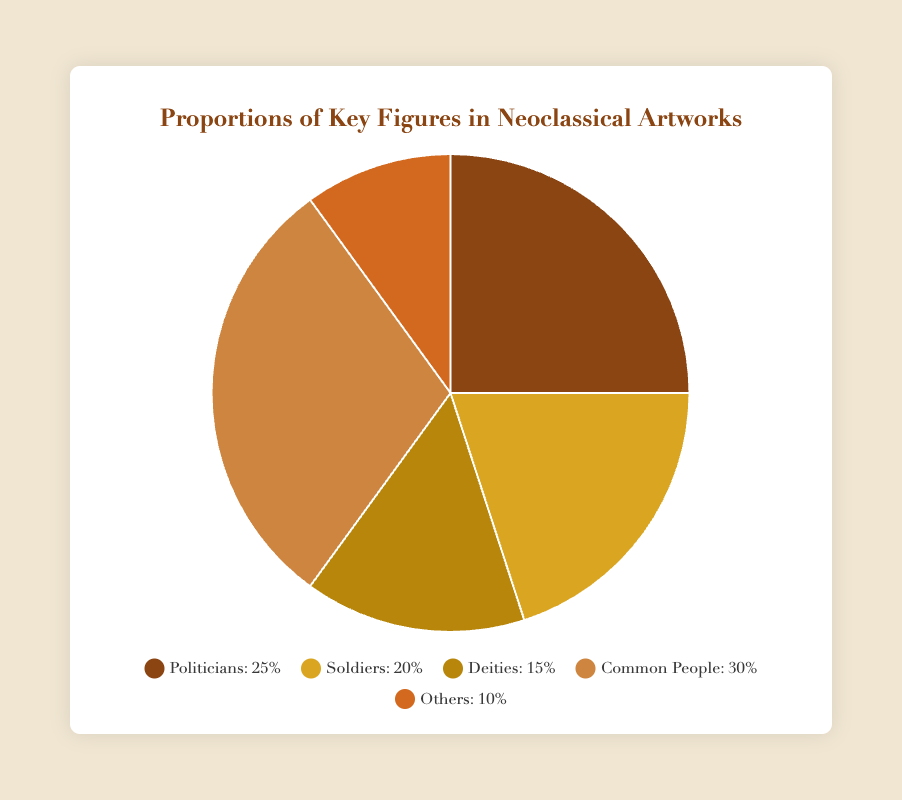What is the proportion of artworks depicting common people? The figure shows that common people make up 30% of the key figures in Neoclassical artworks.
Answer: 30% Which role has the lowest representation in Neoclassical artworks? The figure indicates that the "Others" category, making up 10%, has the lowest representation.
Answer: Others What is the combined proportion of politicians and soldiers in Neoclassical artworks? Politicians make up 25% and soldiers 20%. Adding these percentages gives 25% + 20% = 45%.
Answer: 45% How does the proportion of deities compare to politicians? Deities are 15%, while politicians are 25%. Thus, the proportion of deities is less than that of politicians by 25% - 15% = 10%.
Answer: Deities are less by 10% Which category is roughly twice as represented as deities? Common People make up 30%, and deities make up 15%. 30% is approximately twice 15%.
Answer: Common People If you combine the proportion of soldiers and deities, do they exceed that of common people? Soldiers represent 20%, and deities 15%. Together, they form 20% + 15% = 35%, which exceeds the 30% of common people.
Answer: Yes What is the most visually dominant color in the pie chart based on its proportion? The largest slice, representing common people (30%), will be visually dominant.
Answer: Color for common people What is the average proportion of politicians, soldiers, and deities? The proportions are 25% for politicians, 20% for soldiers, and 15% for deities. The average is (25 + 20 + 15) / 3 = 20%.
Answer: 20% What is the difference in proportions between "others" and the next most common category? Others have 10%, while deities have 15%. The difference is 15% - 10% = 5%.
Answer: 5% How many percentage points greater are common people compared to deities? Common people stand at 30%, and deities at 15%. The difference is 30% - 15% = 15 percentage points.
Answer: 15 